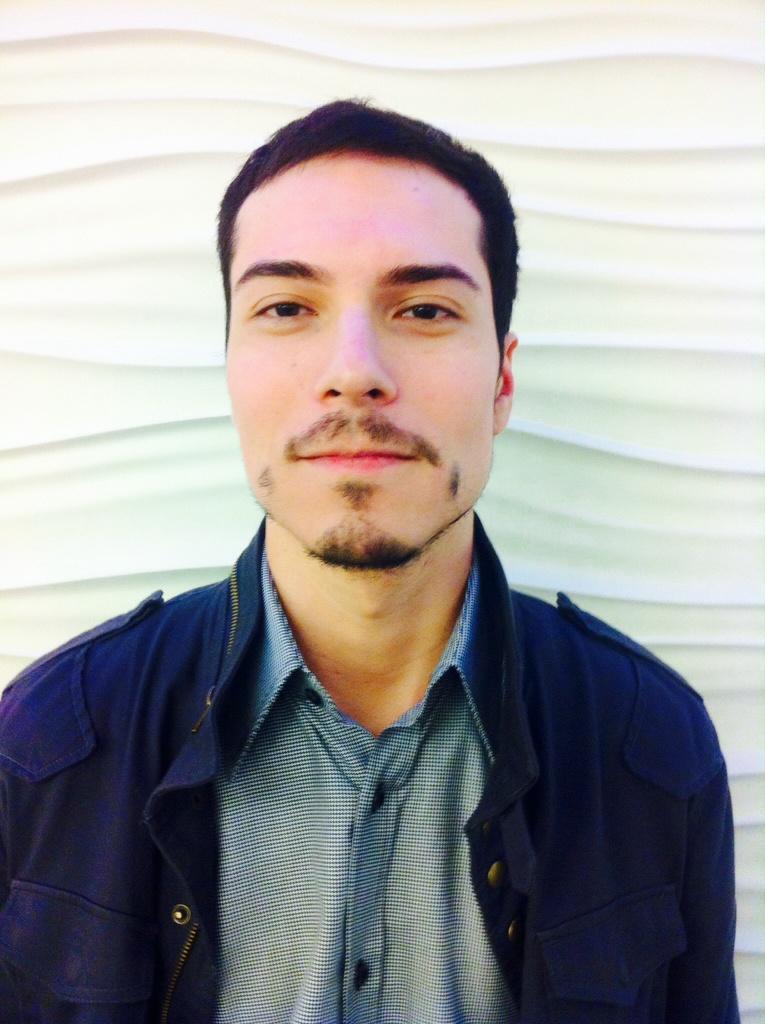How would you summarize this image in a sentence or two? In this image we can see a person wearing a blue color jacket and in the background it looks like the wall. 